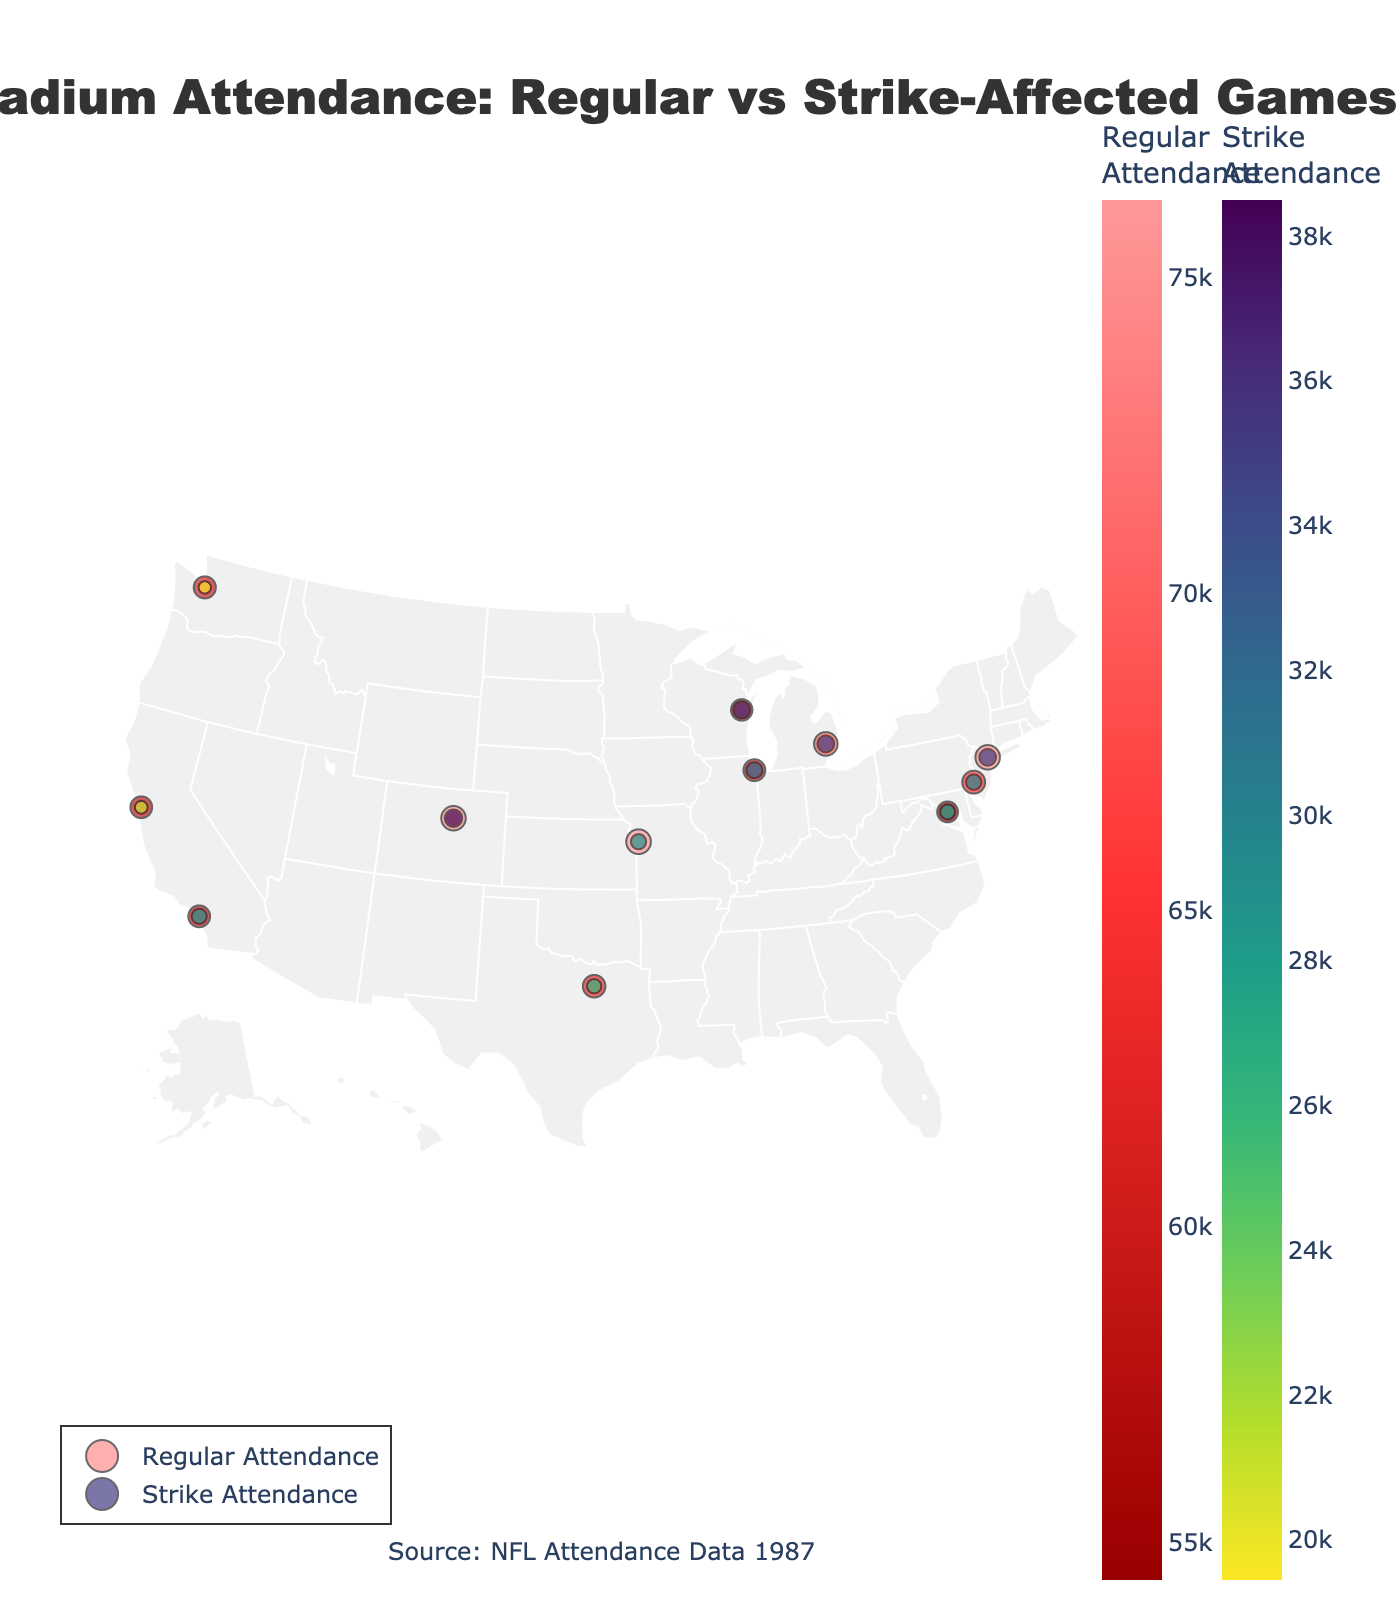What's the title of the plot? The title of a plot is typically located at the top and summarizes the data presented. In this case, it states the subject and timeframe of the data.
Answer: NFL Stadium Attendance: Regular vs Strike-Affected Games (1987) How many data points are represented in the plot? Each data point corresponds to an NFL stadium on the map. By counting all marks, we can determine the number of data points.
Answer: 12 Which stadium had the highest regular game attendance? To find the stadium with the highest regular attendance, locate the largest marker in the color scale for regular attendance.
Answer: Mile High Stadium Which stadium had the lowest strike-affected game attendance? Finding the smallest marker under the color scale for strike attendance will give us the stadium with the lowest strike game attendance.
Answer: Kingdome What is the average attendance decrease percentage due to the strike? To calculate, sum all percentage decreases and divide by the number of stadiums: ((53.15 + 54.68 + 49.04 + 46.27 + 49.88 + 36.93 + 59.21 + 52.02 + 65.00 + 68.17 + 48.75 + 61.83) / 12) = 52.73%
Answer: 52.73% Which state had the largest decrease in attendance during strike games? Based on attendance decrease data and the state each stadium is in, identify which state had the largest overall decrease.
Answer: Washington (DC) Compare the regular and strike attendance for Texas Stadium. Locate Texas Stadium on the plot and compare the sizes and colors of regular and strike attendance markers.
Answer: Regular: 63,855; Strike: 26,042 What's the total strike attendance across all stadiums? Sum the strike attendance figures for all stadiums: 35114 + 29784 + 27728 + 32113 + 35041 + 36455 + 26042 + 28610 + 20778 + 19448 + 38494 + 29082 = 358689
Answer: 358,689 Which stadium showed the smallest percentage decrease in attendance during strike games? Calculate the percentage decrease for each stadium and identify the smallest value: (Regular - Strike) / Regular * 100.
Answer: Lambeau Field How does the attendance decrease at Giants Stadium compare to that at Arrowhead Stadium? Refer to the color and size differences on the plot for both stadiums to compare their attendance decreases.
Answer: Giants Stadium: 53.15%; Arrowhead Stadium: 61.83% 